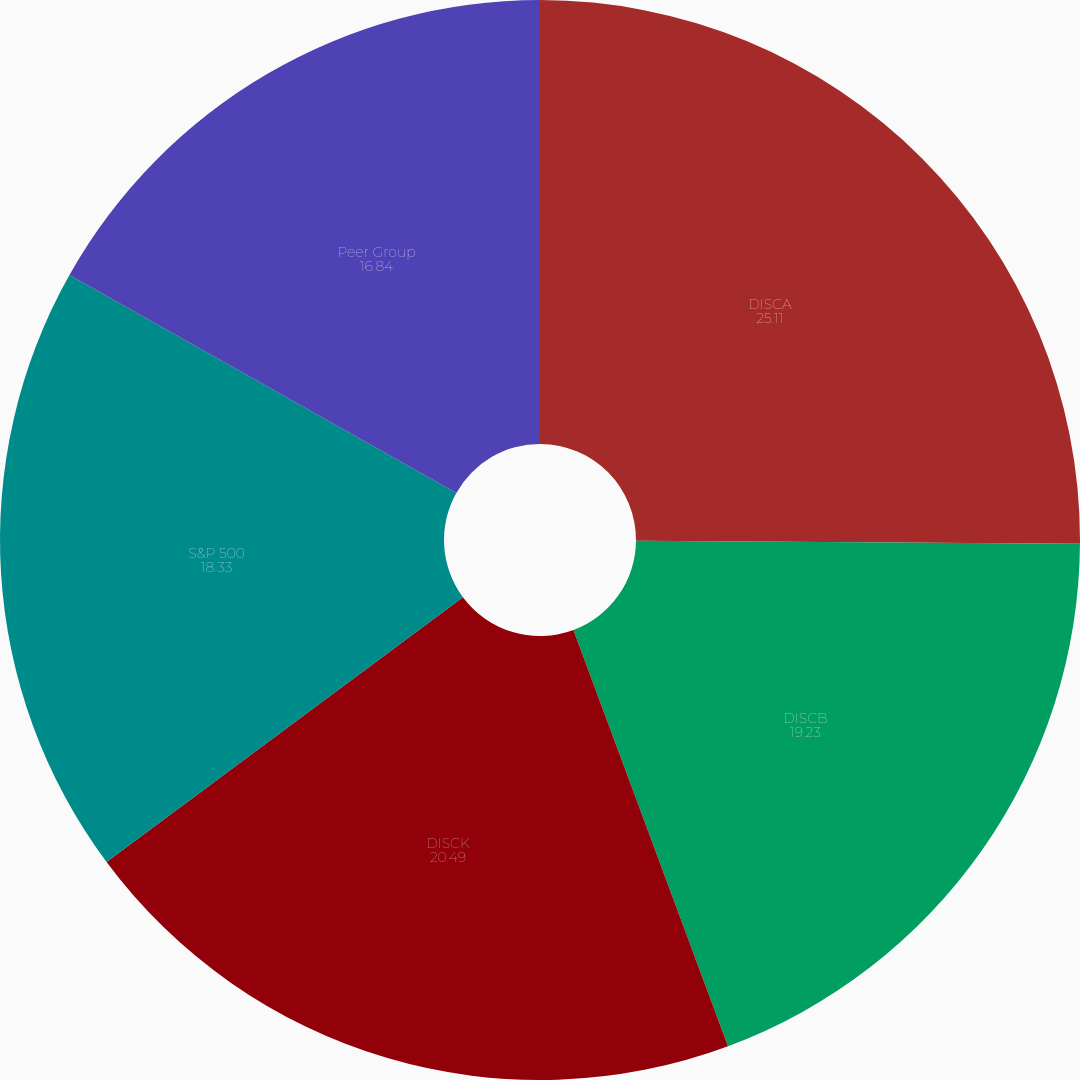<chart> <loc_0><loc_0><loc_500><loc_500><pie_chart><fcel>DISCA<fcel>DISCB<fcel>DISCK<fcel>S&P 500<fcel>Peer Group<nl><fcel>25.11%<fcel>19.23%<fcel>20.49%<fcel>18.33%<fcel>16.84%<nl></chart> 